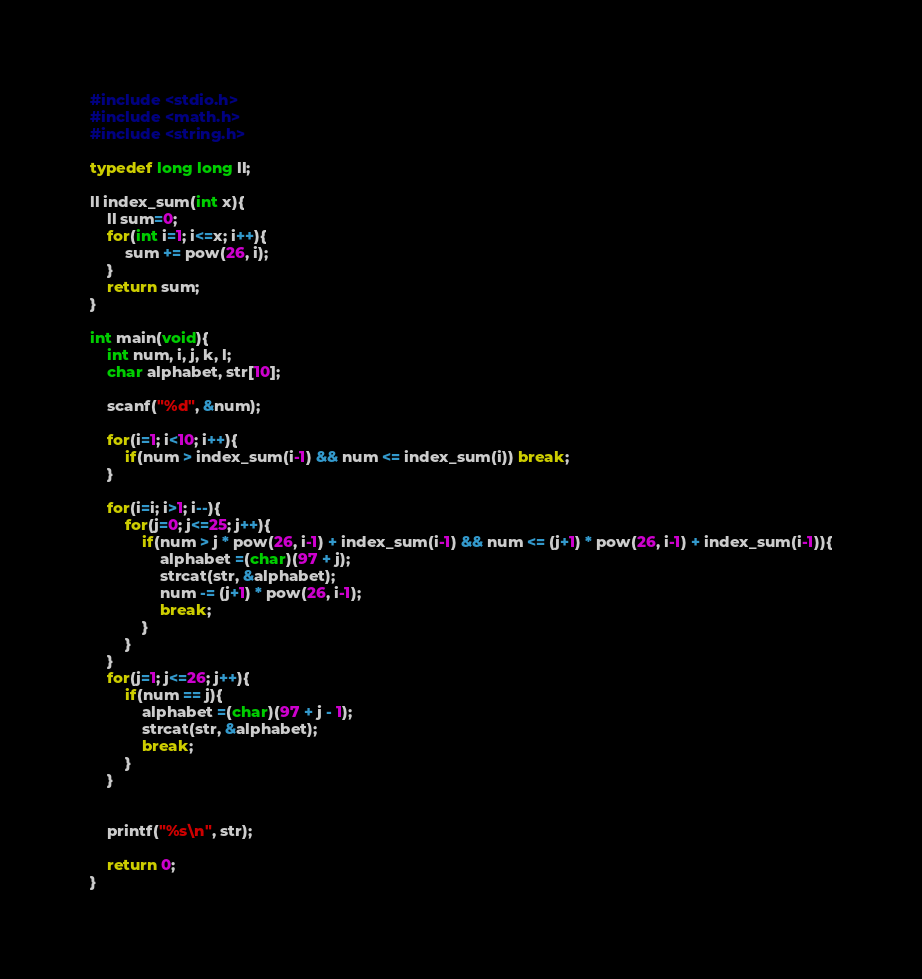<code> <loc_0><loc_0><loc_500><loc_500><_C_>#include <stdio.h>
#include <math.h>
#include <string.h>

typedef long long ll;

ll index_sum(int x){
    ll sum=0;
    for(int i=1; i<=x; i++){
        sum += pow(26, i);
    }
    return sum;
}

int main(void){
    int num, i, j, k, l;
    char alphabet, str[10];

    scanf("%d", &num);

    for(i=1; i<10; i++){
        if(num > index_sum(i-1) && num <= index_sum(i)) break;
    }

    for(i=i; i>1; i--){
        for(j=0; j<=25; j++){
            if(num > j * pow(26, i-1) + index_sum(i-1) && num <= (j+1) * pow(26, i-1) + index_sum(i-1)){
                alphabet =(char)(97 + j);
                strcat(str, &alphabet);
                num -= (j+1) * pow(26, i-1);
                break;
            }
        }
    }
    for(j=1; j<=26; j++){
        if(num == j){
            alphabet =(char)(97 + j - 1);
            strcat(str, &alphabet);
            break;
        }
    }


    printf("%s\n", str);

    return 0;
}
</code> 